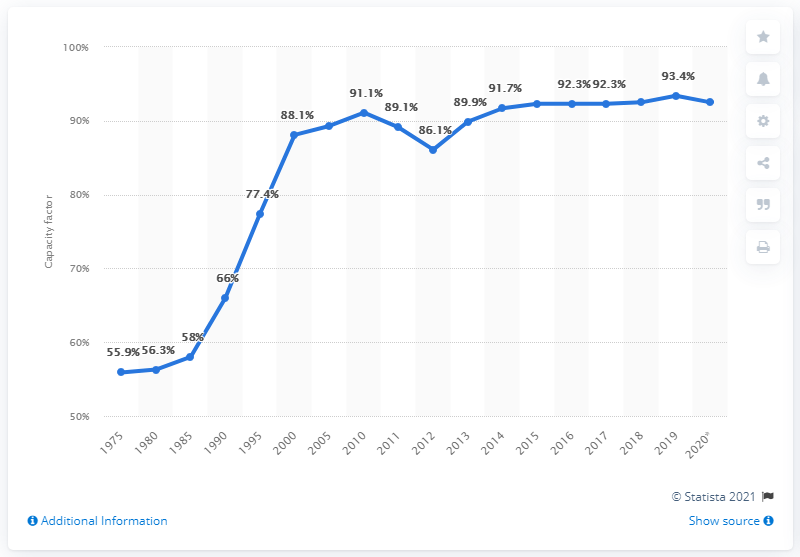Mention a couple of crucial points in this snapshot. The highest capacity factor of nuclear power plants in the United States from 2015 to 2020 was 93.4%. In 2016, the capacity factor of nuclear power plants in the United States was 92.3%. This indicates that the total electricity generated by these plants over the course of the year was 92.3% of their maximum theoretical capacity. The capacity factor of U.S. nuclear power plants peaked in 2019. 